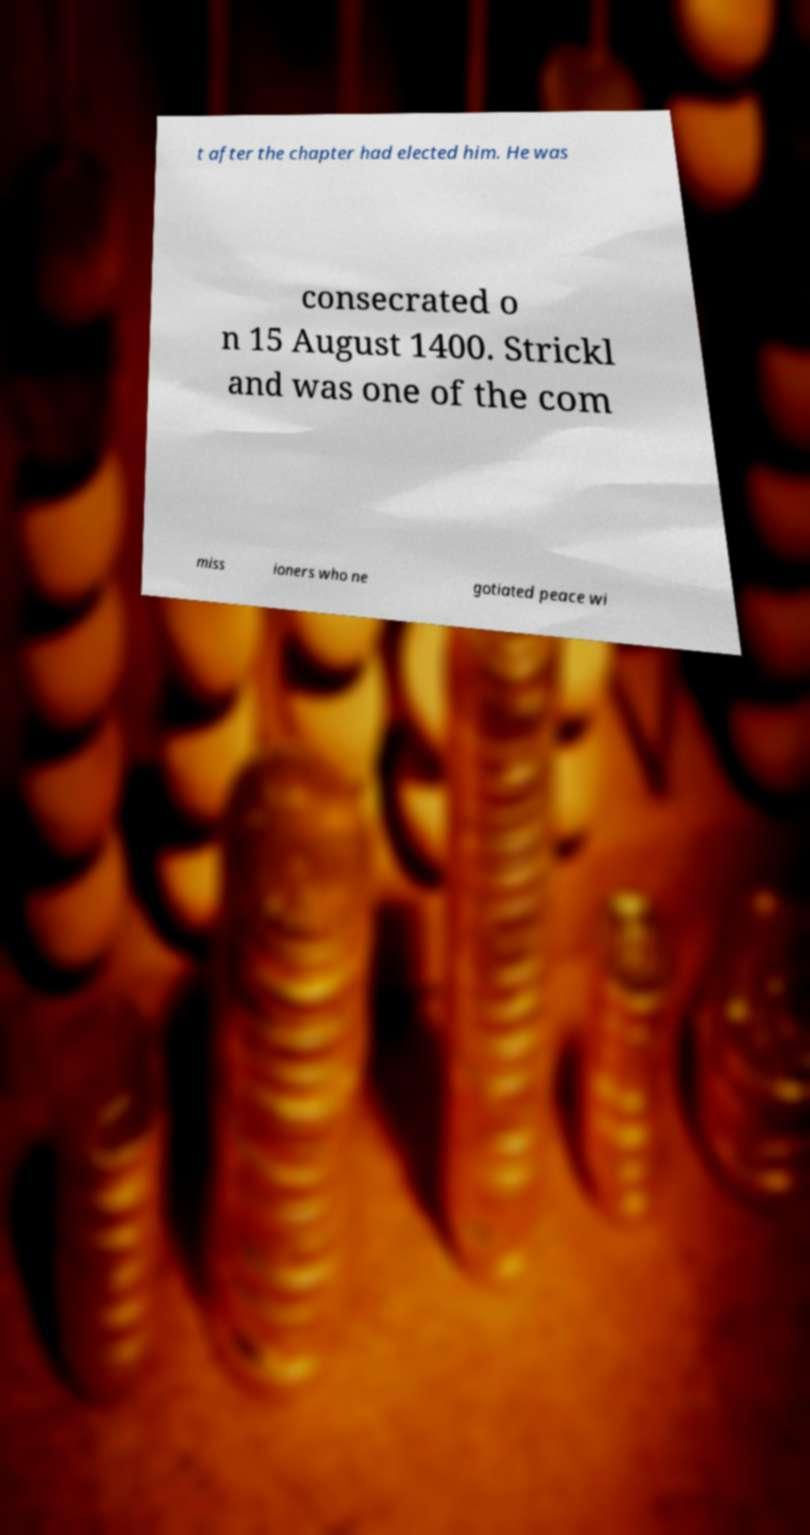Could you extract and type out the text from this image? t after the chapter had elected him. He was consecrated o n 15 August 1400. Strickl and was one of the com miss ioners who ne gotiated peace wi 